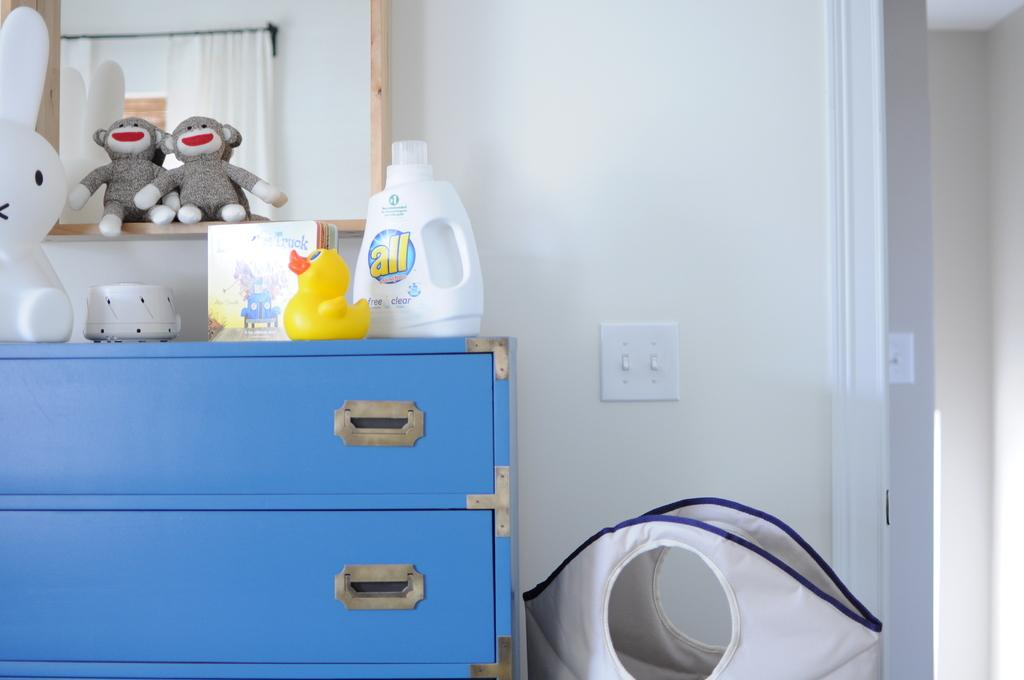What type of furniture is present in the image? There is a cupboard in the image. What can be found inside the cupboard? There are toys inside the cupboard. What is placed on top of the cupboard? There are objects placed on the cupboard. What can be seen in the background of the image? There is a wall in the background of the image. How much coal is stored in the cupboard in the image? There is no coal present in the image; the cupboard contains toys. What advice does the father give in the image? There is no father or any dialogue present in the image. 